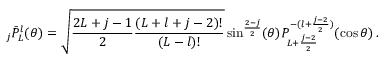<formula> <loc_0><loc_0><loc_500><loc_500>{ } _ { j } { \bar { P } } _ { L } ^ { l } ( \theta ) = { \sqrt { { \frac { 2 L + j - 1 } { 2 } } { \frac { ( L + l + j - 2 ) ! } { ( L - l ) ! } } } } \sin ^ { \frac { 2 - j } { 2 } } ( \theta ) P _ { L + { \frac { j - 2 } { 2 } } } ^ { - ( l + { \frac { j - 2 } { 2 } } ) } ( \cos \theta ) \, .</formula> 